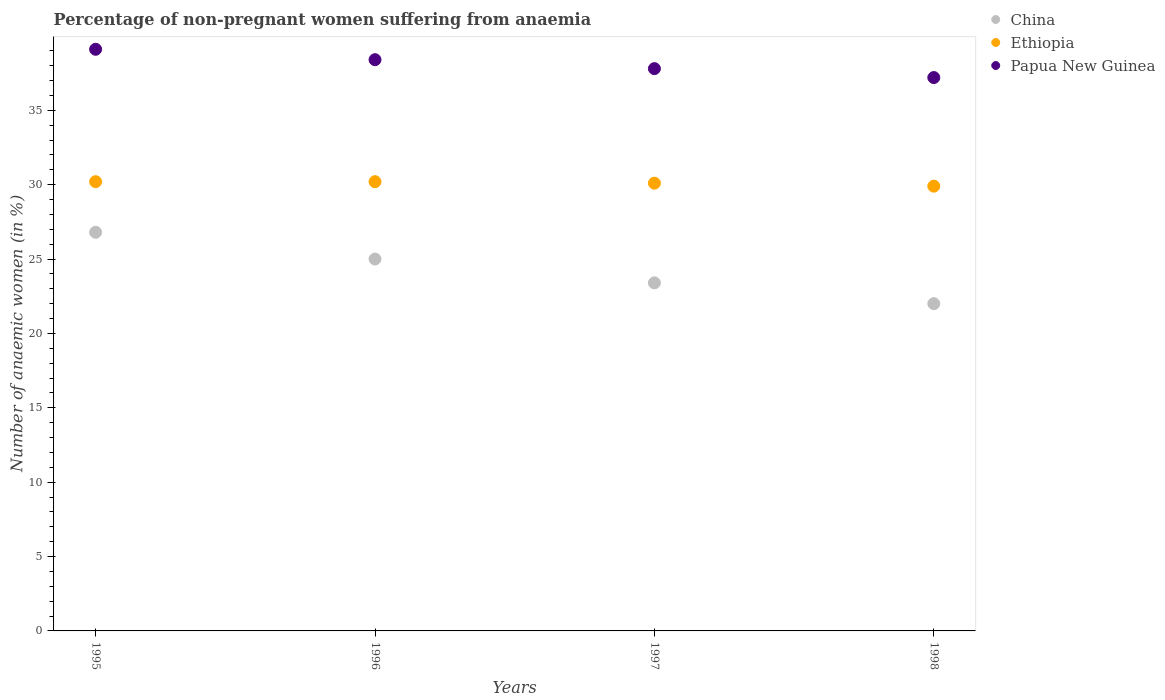Across all years, what is the maximum percentage of non-pregnant women suffering from anaemia in China?
Provide a short and direct response. 26.8. Across all years, what is the minimum percentage of non-pregnant women suffering from anaemia in Papua New Guinea?
Provide a short and direct response. 37.2. In which year was the percentage of non-pregnant women suffering from anaemia in Ethiopia maximum?
Ensure brevity in your answer.  1995. In which year was the percentage of non-pregnant women suffering from anaemia in China minimum?
Offer a terse response. 1998. What is the total percentage of non-pregnant women suffering from anaemia in Ethiopia in the graph?
Provide a succinct answer. 120.4. What is the difference between the percentage of non-pregnant women suffering from anaemia in Papua New Guinea in 1996 and that in 1998?
Provide a succinct answer. 1.2. What is the difference between the percentage of non-pregnant women suffering from anaemia in Ethiopia in 1998 and the percentage of non-pregnant women suffering from anaemia in China in 1997?
Ensure brevity in your answer.  6.5. What is the average percentage of non-pregnant women suffering from anaemia in Papua New Guinea per year?
Offer a very short reply. 38.12. In the year 1996, what is the difference between the percentage of non-pregnant women suffering from anaemia in Ethiopia and percentage of non-pregnant women suffering from anaemia in China?
Provide a succinct answer. 5.2. In how many years, is the percentage of non-pregnant women suffering from anaemia in Ethiopia greater than 15 %?
Provide a short and direct response. 4. What is the ratio of the percentage of non-pregnant women suffering from anaemia in Ethiopia in 1995 to that in 1997?
Offer a very short reply. 1. Is the percentage of non-pregnant women suffering from anaemia in China in 1996 less than that in 1998?
Your answer should be compact. No. What is the difference between the highest and the second highest percentage of non-pregnant women suffering from anaemia in Ethiopia?
Offer a very short reply. 0. What is the difference between the highest and the lowest percentage of non-pregnant women suffering from anaemia in Ethiopia?
Offer a very short reply. 0.3. In how many years, is the percentage of non-pregnant women suffering from anaemia in Ethiopia greater than the average percentage of non-pregnant women suffering from anaemia in Ethiopia taken over all years?
Your answer should be very brief. 2. Is the sum of the percentage of non-pregnant women suffering from anaemia in China in 1996 and 1998 greater than the maximum percentage of non-pregnant women suffering from anaemia in Ethiopia across all years?
Your response must be concise. Yes. Is it the case that in every year, the sum of the percentage of non-pregnant women suffering from anaemia in Papua New Guinea and percentage of non-pregnant women suffering from anaemia in Ethiopia  is greater than the percentage of non-pregnant women suffering from anaemia in China?
Give a very brief answer. Yes. Does the percentage of non-pregnant women suffering from anaemia in Ethiopia monotonically increase over the years?
Your response must be concise. No. Is the percentage of non-pregnant women suffering from anaemia in Ethiopia strictly less than the percentage of non-pregnant women suffering from anaemia in Papua New Guinea over the years?
Make the answer very short. Yes. How many dotlines are there?
Keep it short and to the point. 3. Are the values on the major ticks of Y-axis written in scientific E-notation?
Make the answer very short. No. Does the graph contain any zero values?
Offer a terse response. No. Does the graph contain grids?
Provide a succinct answer. No. Where does the legend appear in the graph?
Give a very brief answer. Top right. What is the title of the graph?
Your response must be concise. Percentage of non-pregnant women suffering from anaemia. Does "Russian Federation" appear as one of the legend labels in the graph?
Offer a terse response. No. What is the label or title of the X-axis?
Your response must be concise. Years. What is the label or title of the Y-axis?
Provide a succinct answer. Number of anaemic women (in %). What is the Number of anaemic women (in %) in China in 1995?
Provide a succinct answer. 26.8. What is the Number of anaemic women (in %) of Ethiopia in 1995?
Provide a succinct answer. 30.2. What is the Number of anaemic women (in %) in Papua New Guinea in 1995?
Offer a very short reply. 39.1. What is the Number of anaemic women (in %) in Ethiopia in 1996?
Offer a very short reply. 30.2. What is the Number of anaemic women (in %) of Papua New Guinea in 1996?
Provide a succinct answer. 38.4. What is the Number of anaemic women (in %) in China in 1997?
Provide a succinct answer. 23.4. What is the Number of anaemic women (in %) of Ethiopia in 1997?
Your response must be concise. 30.1. What is the Number of anaemic women (in %) of Papua New Guinea in 1997?
Provide a short and direct response. 37.8. What is the Number of anaemic women (in %) of China in 1998?
Keep it short and to the point. 22. What is the Number of anaemic women (in %) in Ethiopia in 1998?
Your answer should be compact. 29.9. What is the Number of anaemic women (in %) in Papua New Guinea in 1998?
Give a very brief answer. 37.2. Across all years, what is the maximum Number of anaemic women (in %) in China?
Offer a terse response. 26.8. Across all years, what is the maximum Number of anaemic women (in %) of Ethiopia?
Provide a short and direct response. 30.2. Across all years, what is the maximum Number of anaemic women (in %) in Papua New Guinea?
Offer a terse response. 39.1. Across all years, what is the minimum Number of anaemic women (in %) of China?
Keep it short and to the point. 22. Across all years, what is the minimum Number of anaemic women (in %) in Ethiopia?
Offer a terse response. 29.9. Across all years, what is the minimum Number of anaemic women (in %) of Papua New Guinea?
Make the answer very short. 37.2. What is the total Number of anaemic women (in %) in China in the graph?
Your answer should be compact. 97.2. What is the total Number of anaemic women (in %) in Ethiopia in the graph?
Your response must be concise. 120.4. What is the total Number of anaemic women (in %) in Papua New Guinea in the graph?
Your answer should be very brief. 152.5. What is the difference between the Number of anaemic women (in %) of China in 1995 and that in 1996?
Give a very brief answer. 1.8. What is the difference between the Number of anaemic women (in %) of Ethiopia in 1995 and that in 1996?
Give a very brief answer. 0. What is the difference between the Number of anaemic women (in %) of Papua New Guinea in 1995 and that in 1996?
Ensure brevity in your answer.  0.7. What is the difference between the Number of anaemic women (in %) of Ethiopia in 1995 and that in 1997?
Keep it short and to the point. 0.1. What is the difference between the Number of anaemic women (in %) in Papua New Guinea in 1996 and that in 1997?
Give a very brief answer. 0.6. What is the difference between the Number of anaemic women (in %) in China in 1996 and that in 1998?
Ensure brevity in your answer.  3. What is the difference between the Number of anaemic women (in %) of China in 1997 and that in 1998?
Keep it short and to the point. 1.4. What is the difference between the Number of anaemic women (in %) of Ethiopia in 1997 and that in 1998?
Offer a very short reply. 0.2. What is the difference between the Number of anaemic women (in %) in China in 1995 and the Number of anaemic women (in %) in Papua New Guinea in 1996?
Keep it short and to the point. -11.6. What is the difference between the Number of anaemic women (in %) in China in 1995 and the Number of anaemic women (in %) in Ethiopia in 1997?
Offer a very short reply. -3.3. What is the difference between the Number of anaemic women (in %) in China in 1995 and the Number of anaemic women (in %) in Papua New Guinea in 1997?
Your answer should be very brief. -11. What is the difference between the Number of anaemic women (in %) in Ethiopia in 1996 and the Number of anaemic women (in %) in Papua New Guinea in 1997?
Ensure brevity in your answer.  -7.6. What is the difference between the Number of anaemic women (in %) in China in 1996 and the Number of anaemic women (in %) in Ethiopia in 1998?
Offer a terse response. -4.9. What is the difference between the Number of anaemic women (in %) in China in 1997 and the Number of anaemic women (in %) in Papua New Guinea in 1998?
Your answer should be very brief. -13.8. What is the average Number of anaemic women (in %) of China per year?
Ensure brevity in your answer.  24.3. What is the average Number of anaemic women (in %) in Ethiopia per year?
Provide a succinct answer. 30.1. What is the average Number of anaemic women (in %) of Papua New Guinea per year?
Keep it short and to the point. 38.12. In the year 1995, what is the difference between the Number of anaemic women (in %) of China and Number of anaemic women (in %) of Papua New Guinea?
Offer a very short reply. -12.3. In the year 1995, what is the difference between the Number of anaemic women (in %) in Ethiopia and Number of anaemic women (in %) in Papua New Guinea?
Offer a very short reply. -8.9. In the year 1996, what is the difference between the Number of anaemic women (in %) in China and Number of anaemic women (in %) in Papua New Guinea?
Give a very brief answer. -13.4. In the year 1996, what is the difference between the Number of anaemic women (in %) in Ethiopia and Number of anaemic women (in %) in Papua New Guinea?
Provide a succinct answer. -8.2. In the year 1997, what is the difference between the Number of anaemic women (in %) of China and Number of anaemic women (in %) of Ethiopia?
Your answer should be compact. -6.7. In the year 1997, what is the difference between the Number of anaemic women (in %) in China and Number of anaemic women (in %) in Papua New Guinea?
Keep it short and to the point. -14.4. In the year 1998, what is the difference between the Number of anaemic women (in %) in China and Number of anaemic women (in %) in Papua New Guinea?
Offer a terse response. -15.2. What is the ratio of the Number of anaemic women (in %) in China in 1995 to that in 1996?
Keep it short and to the point. 1.07. What is the ratio of the Number of anaemic women (in %) of Papua New Guinea in 1995 to that in 1996?
Keep it short and to the point. 1.02. What is the ratio of the Number of anaemic women (in %) of China in 1995 to that in 1997?
Make the answer very short. 1.15. What is the ratio of the Number of anaemic women (in %) in Ethiopia in 1995 to that in 1997?
Offer a terse response. 1. What is the ratio of the Number of anaemic women (in %) in Papua New Guinea in 1995 to that in 1997?
Give a very brief answer. 1.03. What is the ratio of the Number of anaemic women (in %) of China in 1995 to that in 1998?
Make the answer very short. 1.22. What is the ratio of the Number of anaemic women (in %) in Papua New Guinea in 1995 to that in 1998?
Your response must be concise. 1.05. What is the ratio of the Number of anaemic women (in %) in China in 1996 to that in 1997?
Ensure brevity in your answer.  1.07. What is the ratio of the Number of anaemic women (in %) of Ethiopia in 1996 to that in 1997?
Keep it short and to the point. 1. What is the ratio of the Number of anaemic women (in %) of Papua New Guinea in 1996 to that in 1997?
Keep it short and to the point. 1.02. What is the ratio of the Number of anaemic women (in %) of China in 1996 to that in 1998?
Your response must be concise. 1.14. What is the ratio of the Number of anaemic women (in %) of Ethiopia in 1996 to that in 1998?
Offer a terse response. 1.01. What is the ratio of the Number of anaemic women (in %) in Papua New Guinea in 1996 to that in 1998?
Your answer should be compact. 1.03. What is the ratio of the Number of anaemic women (in %) of China in 1997 to that in 1998?
Offer a very short reply. 1.06. What is the ratio of the Number of anaemic women (in %) of Ethiopia in 1997 to that in 1998?
Give a very brief answer. 1.01. What is the ratio of the Number of anaemic women (in %) in Papua New Guinea in 1997 to that in 1998?
Provide a succinct answer. 1.02. What is the difference between the highest and the second highest Number of anaemic women (in %) of Papua New Guinea?
Offer a very short reply. 0.7. What is the difference between the highest and the lowest Number of anaemic women (in %) of China?
Give a very brief answer. 4.8. What is the difference between the highest and the lowest Number of anaemic women (in %) in Papua New Guinea?
Keep it short and to the point. 1.9. 